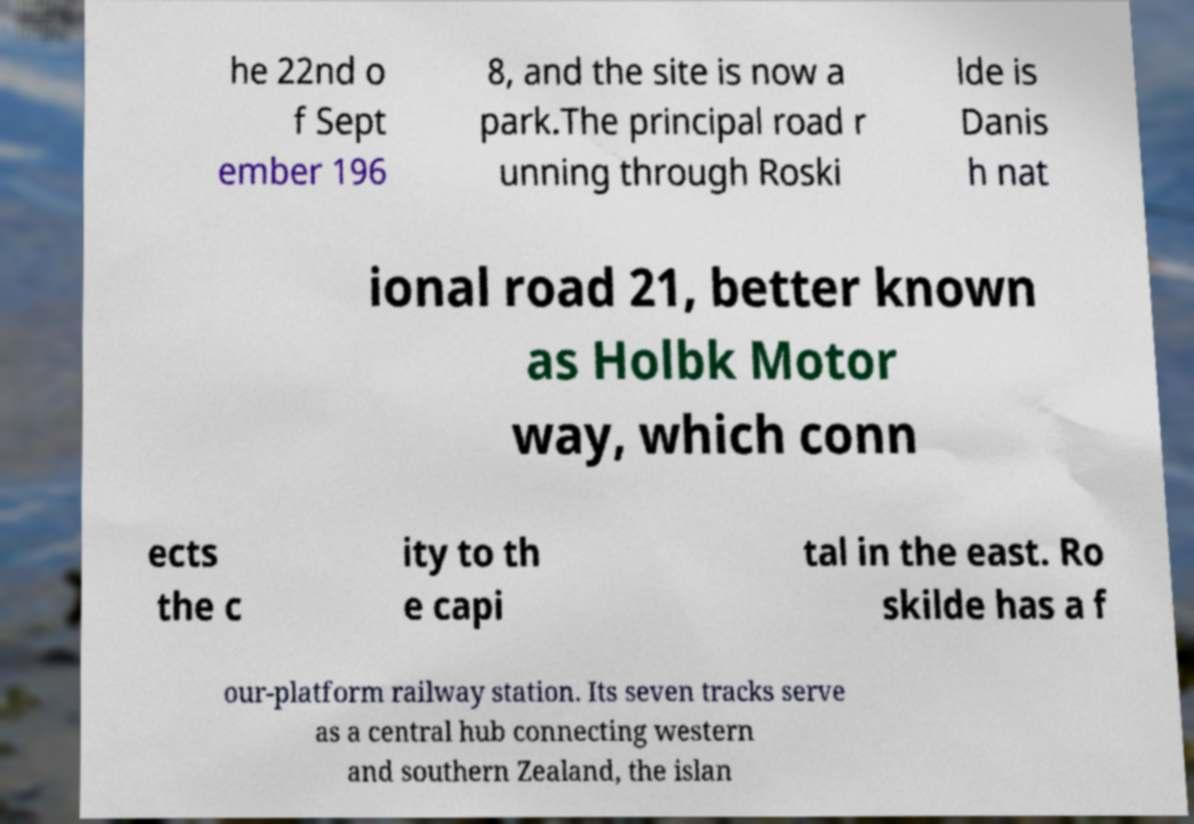Please read and relay the text visible in this image. What does it say? he 22nd o f Sept ember 196 8, and the site is now a park.The principal road r unning through Roski lde is Danis h nat ional road 21, better known as Holbk Motor way, which conn ects the c ity to th e capi tal in the east. Ro skilde has a f our-platform railway station. Its seven tracks serve as a central hub connecting western and southern Zealand, the islan 